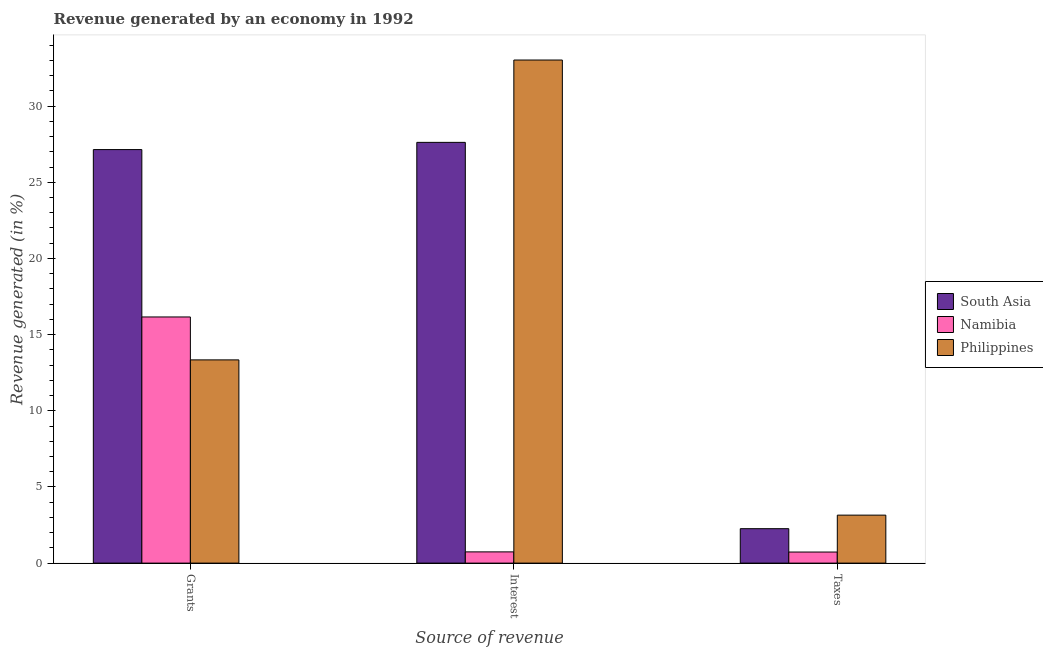How many different coloured bars are there?
Provide a short and direct response. 3. How many groups of bars are there?
Make the answer very short. 3. Are the number of bars per tick equal to the number of legend labels?
Ensure brevity in your answer.  Yes. Are the number of bars on each tick of the X-axis equal?
Your answer should be compact. Yes. How many bars are there on the 1st tick from the left?
Your answer should be compact. 3. How many bars are there on the 3rd tick from the right?
Make the answer very short. 3. What is the label of the 1st group of bars from the left?
Offer a very short reply. Grants. What is the percentage of revenue generated by interest in Philippines?
Provide a succinct answer. 33.03. Across all countries, what is the maximum percentage of revenue generated by interest?
Give a very brief answer. 33.03. Across all countries, what is the minimum percentage of revenue generated by taxes?
Your answer should be very brief. 0.73. In which country was the percentage of revenue generated by interest maximum?
Give a very brief answer. Philippines. In which country was the percentage of revenue generated by grants minimum?
Provide a succinct answer. Philippines. What is the total percentage of revenue generated by taxes in the graph?
Your response must be concise. 6.14. What is the difference between the percentage of revenue generated by taxes in Philippines and that in Namibia?
Provide a short and direct response. 2.42. What is the difference between the percentage of revenue generated by interest in Namibia and the percentage of revenue generated by grants in South Asia?
Your response must be concise. -26.41. What is the average percentage of revenue generated by interest per country?
Your answer should be very brief. 20.46. What is the difference between the percentage of revenue generated by taxes and percentage of revenue generated by interest in Namibia?
Provide a short and direct response. -0.01. What is the ratio of the percentage of revenue generated by interest in Philippines to that in South Asia?
Give a very brief answer. 1.2. Is the difference between the percentage of revenue generated by taxes in South Asia and Philippines greater than the difference between the percentage of revenue generated by interest in South Asia and Philippines?
Your response must be concise. Yes. What is the difference between the highest and the second highest percentage of revenue generated by taxes?
Ensure brevity in your answer.  0.89. What is the difference between the highest and the lowest percentage of revenue generated by taxes?
Provide a succinct answer. 2.42. In how many countries, is the percentage of revenue generated by taxes greater than the average percentage of revenue generated by taxes taken over all countries?
Provide a succinct answer. 2. Is the sum of the percentage of revenue generated by grants in Namibia and Philippines greater than the maximum percentage of revenue generated by interest across all countries?
Provide a succinct answer. No. What does the 3rd bar from the left in Interest represents?
Your response must be concise. Philippines. What does the 1st bar from the right in Taxes represents?
Keep it short and to the point. Philippines. Are all the bars in the graph horizontal?
Offer a very short reply. No. How many countries are there in the graph?
Make the answer very short. 3. What is the difference between two consecutive major ticks on the Y-axis?
Give a very brief answer. 5. Does the graph contain grids?
Your answer should be very brief. No. How many legend labels are there?
Give a very brief answer. 3. What is the title of the graph?
Give a very brief answer. Revenue generated by an economy in 1992. Does "Ireland" appear as one of the legend labels in the graph?
Your answer should be very brief. No. What is the label or title of the X-axis?
Give a very brief answer. Source of revenue. What is the label or title of the Y-axis?
Offer a terse response. Revenue generated (in %). What is the Revenue generated (in %) in South Asia in Grants?
Ensure brevity in your answer.  27.15. What is the Revenue generated (in %) in Namibia in Grants?
Provide a succinct answer. 16.16. What is the Revenue generated (in %) in Philippines in Grants?
Provide a short and direct response. 13.34. What is the Revenue generated (in %) in South Asia in Interest?
Make the answer very short. 27.62. What is the Revenue generated (in %) of Namibia in Interest?
Keep it short and to the point. 0.74. What is the Revenue generated (in %) of Philippines in Interest?
Your response must be concise. 33.03. What is the Revenue generated (in %) of South Asia in Taxes?
Your response must be concise. 2.26. What is the Revenue generated (in %) in Namibia in Taxes?
Make the answer very short. 0.73. What is the Revenue generated (in %) of Philippines in Taxes?
Ensure brevity in your answer.  3.15. Across all Source of revenue, what is the maximum Revenue generated (in %) of South Asia?
Make the answer very short. 27.62. Across all Source of revenue, what is the maximum Revenue generated (in %) in Namibia?
Ensure brevity in your answer.  16.16. Across all Source of revenue, what is the maximum Revenue generated (in %) of Philippines?
Make the answer very short. 33.03. Across all Source of revenue, what is the minimum Revenue generated (in %) in South Asia?
Offer a very short reply. 2.26. Across all Source of revenue, what is the minimum Revenue generated (in %) of Namibia?
Offer a terse response. 0.73. Across all Source of revenue, what is the minimum Revenue generated (in %) of Philippines?
Provide a succinct answer. 3.15. What is the total Revenue generated (in %) of South Asia in the graph?
Keep it short and to the point. 57.03. What is the total Revenue generated (in %) of Namibia in the graph?
Offer a very short reply. 17.62. What is the total Revenue generated (in %) in Philippines in the graph?
Offer a terse response. 49.52. What is the difference between the Revenue generated (in %) in South Asia in Grants and that in Interest?
Ensure brevity in your answer.  -0.47. What is the difference between the Revenue generated (in %) in Namibia in Grants and that in Interest?
Your answer should be very brief. 15.42. What is the difference between the Revenue generated (in %) in Philippines in Grants and that in Interest?
Your response must be concise. -19.69. What is the difference between the Revenue generated (in %) in South Asia in Grants and that in Taxes?
Ensure brevity in your answer.  24.89. What is the difference between the Revenue generated (in %) in Namibia in Grants and that in Taxes?
Give a very brief answer. 15.43. What is the difference between the Revenue generated (in %) of Philippines in Grants and that in Taxes?
Make the answer very short. 10.19. What is the difference between the Revenue generated (in %) of South Asia in Interest and that in Taxes?
Give a very brief answer. 25.36. What is the difference between the Revenue generated (in %) in Namibia in Interest and that in Taxes?
Offer a very short reply. 0.01. What is the difference between the Revenue generated (in %) of Philippines in Interest and that in Taxes?
Offer a terse response. 29.88. What is the difference between the Revenue generated (in %) of South Asia in Grants and the Revenue generated (in %) of Namibia in Interest?
Provide a succinct answer. 26.41. What is the difference between the Revenue generated (in %) of South Asia in Grants and the Revenue generated (in %) of Philippines in Interest?
Keep it short and to the point. -5.88. What is the difference between the Revenue generated (in %) in Namibia in Grants and the Revenue generated (in %) in Philippines in Interest?
Make the answer very short. -16.87. What is the difference between the Revenue generated (in %) of South Asia in Grants and the Revenue generated (in %) of Namibia in Taxes?
Your answer should be compact. 26.42. What is the difference between the Revenue generated (in %) in South Asia in Grants and the Revenue generated (in %) in Philippines in Taxes?
Offer a very short reply. 24. What is the difference between the Revenue generated (in %) in Namibia in Grants and the Revenue generated (in %) in Philippines in Taxes?
Ensure brevity in your answer.  13.01. What is the difference between the Revenue generated (in %) of South Asia in Interest and the Revenue generated (in %) of Namibia in Taxes?
Provide a short and direct response. 26.89. What is the difference between the Revenue generated (in %) in South Asia in Interest and the Revenue generated (in %) in Philippines in Taxes?
Offer a terse response. 24.47. What is the difference between the Revenue generated (in %) of Namibia in Interest and the Revenue generated (in %) of Philippines in Taxes?
Give a very brief answer. -2.41. What is the average Revenue generated (in %) of South Asia per Source of revenue?
Offer a terse response. 19.01. What is the average Revenue generated (in %) of Namibia per Source of revenue?
Give a very brief answer. 5.87. What is the average Revenue generated (in %) of Philippines per Source of revenue?
Provide a short and direct response. 16.51. What is the difference between the Revenue generated (in %) in South Asia and Revenue generated (in %) in Namibia in Grants?
Ensure brevity in your answer.  10.99. What is the difference between the Revenue generated (in %) in South Asia and Revenue generated (in %) in Philippines in Grants?
Keep it short and to the point. 13.81. What is the difference between the Revenue generated (in %) of Namibia and Revenue generated (in %) of Philippines in Grants?
Provide a succinct answer. 2.82. What is the difference between the Revenue generated (in %) in South Asia and Revenue generated (in %) in Namibia in Interest?
Provide a short and direct response. 26.88. What is the difference between the Revenue generated (in %) of South Asia and Revenue generated (in %) of Philippines in Interest?
Ensure brevity in your answer.  -5.41. What is the difference between the Revenue generated (in %) of Namibia and Revenue generated (in %) of Philippines in Interest?
Provide a succinct answer. -32.29. What is the difference between the Revenue generated (in %) of South Asia and Revenue generated (in %) of Namibia in Taxes?
Give a very brief answer. 1.53. What is the difference between the Revenue generated (in %) of South Asia and Revenue generated (in %) of Philippines in Taxes?
Ensure brevity in your answer.  -0.89. What is the difference between the Revenue generated (in %) of Namibia and Revenue generated (in %) of Philippines in Taxes?
Provide a succinct answer. -2.42. What is the ratio of the Revenue generated (in %) of South Asia in Grants to that in Interest?
Give a very brief answer. 0.98. What is the ratio of the Revenue generated (in %) of Namibia in Grants to that in Interest?
Keep it short and to the point. 21.91. What is the ratio of the Revenue generated (in %) in Philippines in Grants to that in Interest?
Give a very brief answer. 0.4. What is the ratio of the Revenue generated (in %) in South Asia in Grants to that in Taxes?
Ensure brevity in your answer.  12.01. What is the ratio of the Revenue generated (in %) of Namibia in Grants to that in Taxes?
Give a very brief answer. 22.22. What is the ratio of the Revenue generated (in %) in Philippines in Grants to that in Taxes?
Keep it short and to the point. 4.24. What is the ratio of the Revenue generated (in %) in South Asia in Interest to that in Taxes?
Provide a short and direct response. 12.22. What is the ratio of the Revenue generated (in %) in Namibia in Interest to that in Taxes?
Provide a short and direct response. 1.01. What is the ratio of the Revenue generated (in %) of Philippines in Interest to that in Taxes?
Provide a succinct answer. 10.48. What is the difference between the highest and the second highest Revenue generated (in %) in South Asia?
Ensure brevity in your answer.  0.47. What is the difference between the highest and the second highest Revenue generated (in %) in Namibia?
Give a very brief answer. 15.42. What is the difference between the highest and the second highest Revenue generated (in %) in Philippines?
Your answer should be very brief. 19.69. What is the difference between the highest and the lowest Revenue generated (in %) in South Asia?
Ensure brevity in your answer.  25.36. What is the difference between the highest and the lowest Revenue generated (in %) of Namibia?
Your answer should be compact. 15.43. What is the difference between the highest and the lowest Revenue generated (in %) in Philippines?
Give a very brief answer. 29.88. 